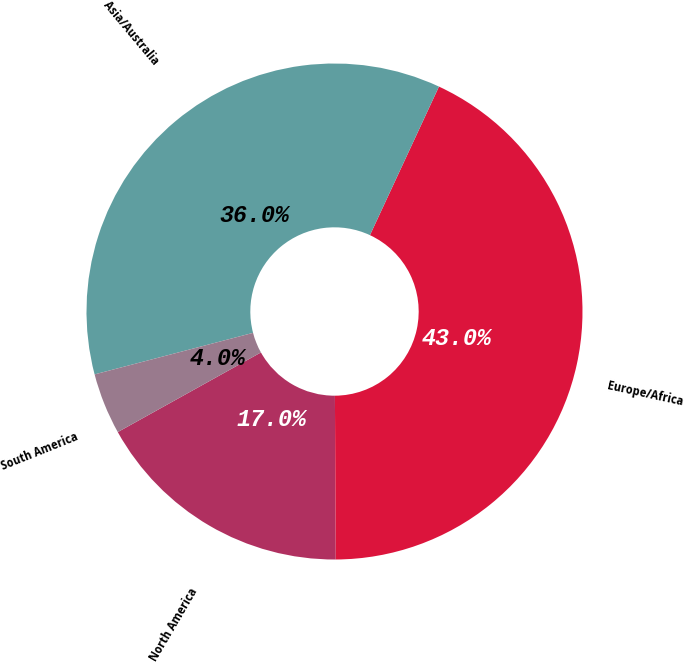<chart> <loc_0><loc_0><loc_500><loc_500><pie_chart><fcel>North America<fcel>Europe/Africa<fcel>Asia/Australia<fcel>South America<nl><fcel>17.0%<fcel>43.0%<fcel>36.0%<fcel>4.0%<nl></chart> 